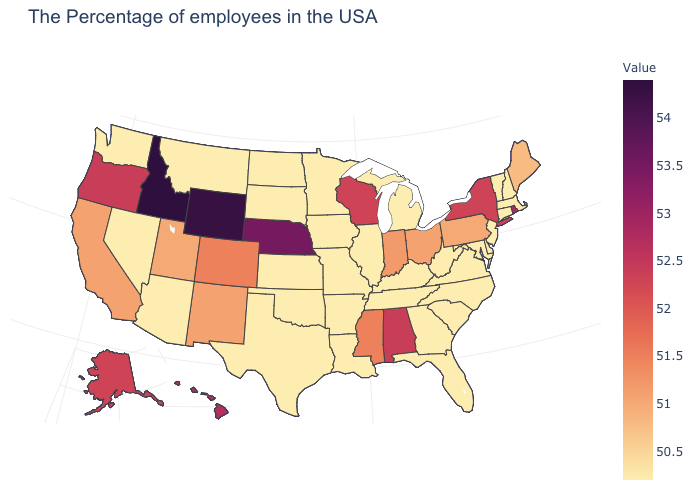Is the legend a continuous bar?
Write a very short answer. Yes. Does the map have missing data?
Quick response, please. No. Among the states that border Tennessee , does Mississippi have the lowest value?
Quick response, please. No. Does Idaho have the highest value in the USA?
Quick response, please. Yes. Does the map have missing data?
Give a very brief answer. No. 